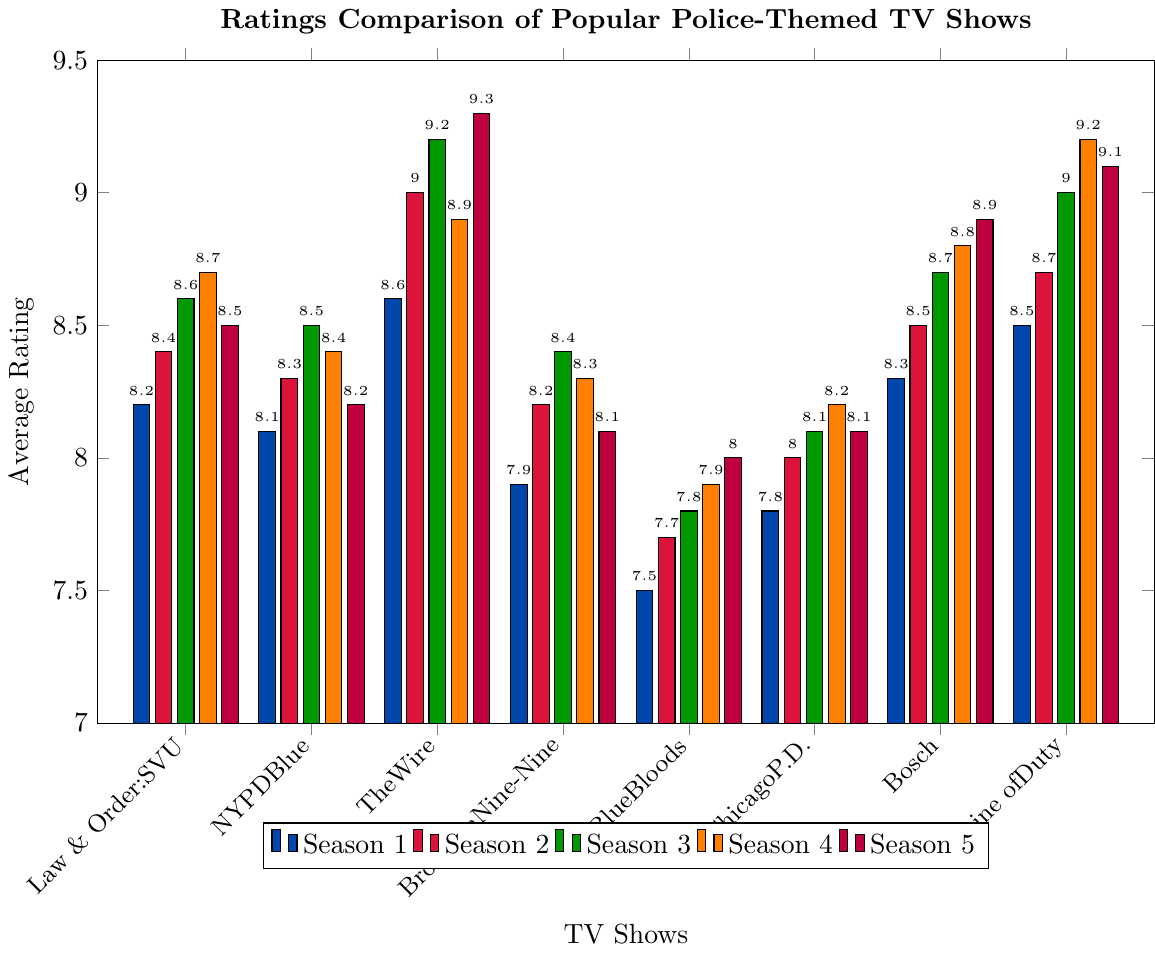which TV show had the highest rating in season 3? Look at the bars corresponding to season 3 for each TV show, the tallest bar indicates the highest rating, and it belongs to "The Wire" with a rating of 9.2
Answer: The Wire Compare the average rating of seasons 1 and 5 for "Line of Duty". Which one's higher? Find the ratings for "Line of Duty" in seasons 1 and 5, average them: Season 1 (8.5) and Season 5 (9.1). Season 5 has a higher rating.
Answer: Season 5 What's the overall trend in ratings for "Brooklyn Nine-Nine" across the seasons? Observe the bar heights for "Brooklyn Nine-Nine" from season 1 to 5, which shows a slight increase initially, then a small decline by season 5.
Answer: Increasing then slightly decreasing Which TV show saw the most improvement from season 1 to season 5? Calculate the difference in ratings from season 1 to season 5 for each show, the largest difference is for "Line of Duty" (9.1 - 8.5 = 0.6).
Answer: Line of Duty If you average the ratings of season 2 across all TV shows, what do you get? Sum the ratings for season 2 across all shows and divide by the number of shows: (8.4 + 8.3 + 9.0 + 8.2 + 7.7 + 8.0 + 8.5 + 8.7)/8 = 8.35
Answer: 8.35 How does the rating of "Chicago P.D." in season 4 compare to its rating in season 3? Locate the bars for "Chicago P.D." in seasons 3 and 4, season 3 is 8.1 and season 4 is 8.2, showing a slight increase.
Answer: Slight Increase Which season shows the highest average rating for "Bosch"? Check the ratings for "Bosch" across all seasons and find the average for each, season 5 has the highest rating of 8.9.
Answer: Season 5 Did "Blue Bloods" have a consistent increase in ratings across the seasons? Observe the bar heights for "Blue Bloods" from seasons 1 to 5, each season shows a steady increase in rating.
Answer: Yes Which show sees a decline in its rating in the final season compared to the previous season? Look for TV shows where the rating of season 5 is lower than season 4, "Law & Order: SVU" fits this with a decline from 8.7 to 8.5.
Answer: Law & Order: SVU Based on the visual attributes, which season is represented by the orange bars? Identify the color of the bars for each season in the legend, the orange bars correspond to season 4.
Answer: Season 4 